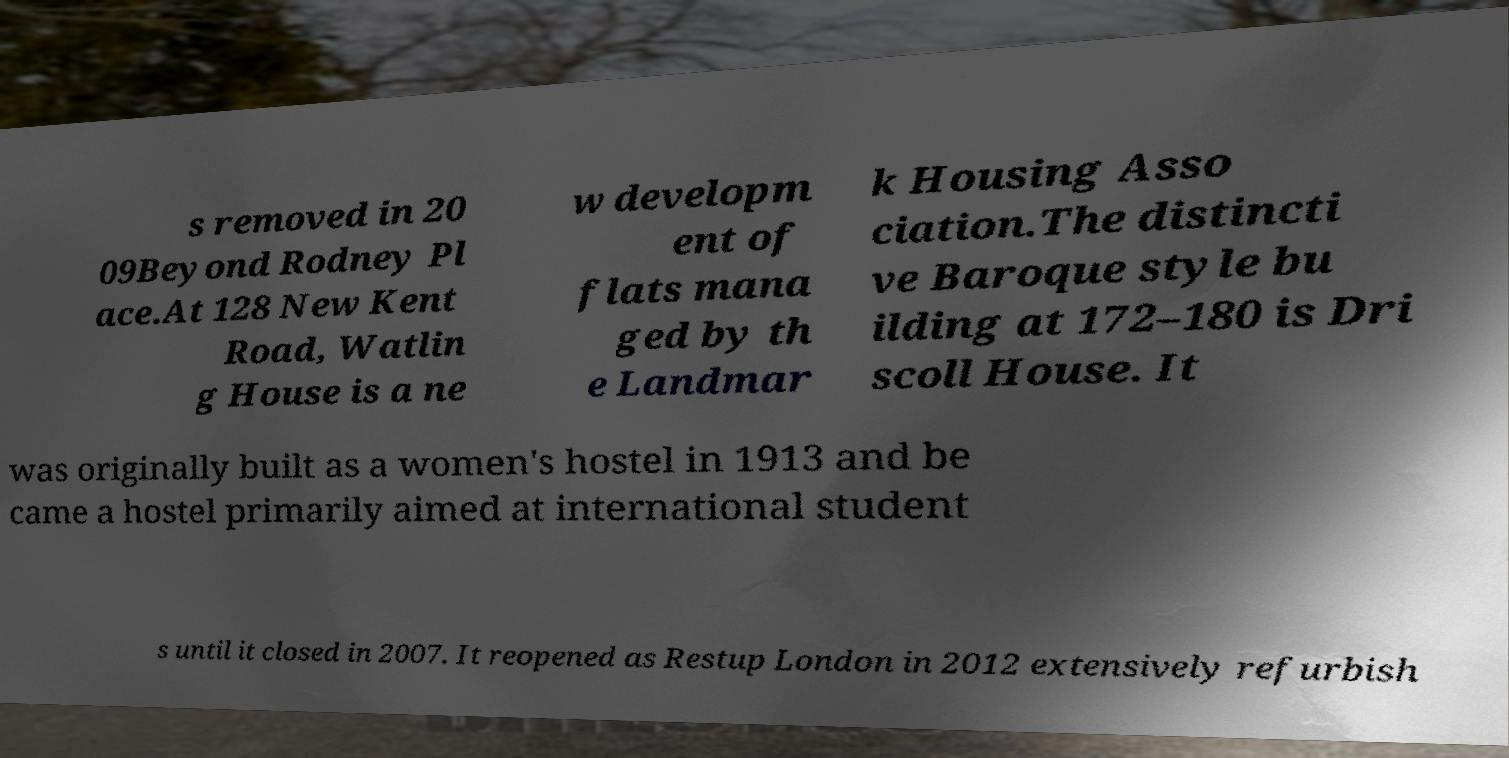I need the written content from this picture converted into text. Can you do that? s removed in 20 09Beyond Rodney Pl ace.At 128 New Kent Road, Watlin g House is a ne w developm ent of flats mana ged by th e Landmar k Housing Asso ciation.The distincti ve Baroque style bu ilding at 172–180 is Dri scoll House. It was originally built as a women's hostel in 1913 and be came a hostel primarily aimed at international student s until it closed in 2007. It reopened as Restup London in 2012 extensively refurbish 